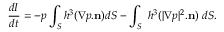<formula> <loc_0><loc_0><loc_500><loc_500>\frac { d I } { d t } = - p \int _ { S } h ^ { 3 } ( \nabla p . n ) d S - \int _ { S } \ h ^ { 3 } ( | \nabla p | ^ { 2 } . n ) \ d S .</formula> 